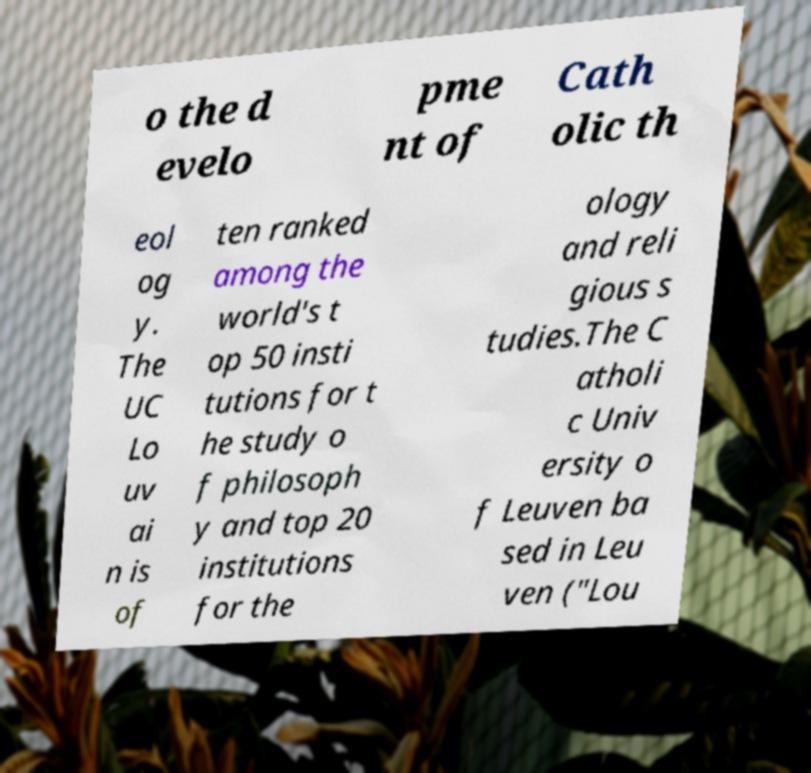There's text embedded in this image that I need extracted. Can you transcribe it verbatim? o the d evelo pme nt of Cath olic th eol og y. The UC Lo uv ai n is of ten ranked among the world's t op 50 insti tutions for t he study o f philosoph y and top 20 institutions for the ology and reli gious s tudies.The C atholi c Univ ersity o f Leuven ba sed in Leu ven ("Lou 